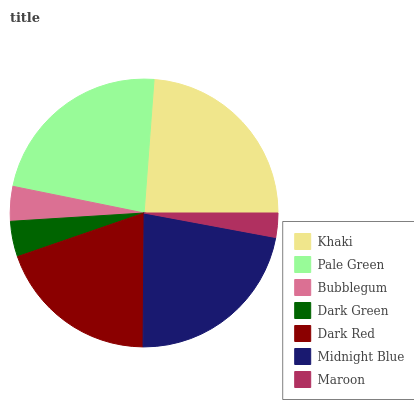Is Maroon the minimum?
Answer yes or no. Yes. Is Khaki the maximum?
Answer yes or no. Yes. Is Pale Green the minimum?
Answer yes or no. No. Is Pale Green the maximum?
Answer yes or no. No. Is Khaki greater than Pale Green?
Answer yes or no. Yes. Is Pale Green less than Khaki?
Answer yes or no. Yes. Is Pale Green greater than Khaki?
Answer yes or no. No. Is Khaki less than Pale Green?
Answer yes or no. No. Is Dark Red the high median?
Answer yes or no. Yes. Is Dark Red the low median?
Answer yes or no. Yes. Is Maroon the high median?
Answer yes or no. No. Is Maroon the low median?
Answer yes or no. No. 